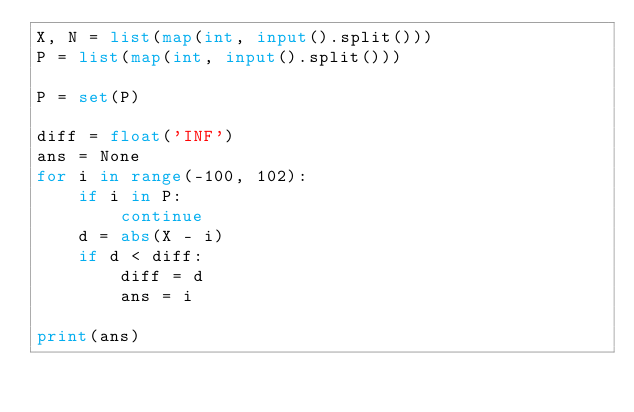<code> <loc_0><loc_0><loc_500><loc_500><_Python_>X, N = list(map(int, input().split()))
P = list(map(int, input().split()))

P = set(P)

diff = float('INF')
ans = None
for i in range(-100, 102):
    if i in P:
        continue
    d = abs(X - i)
    if d < diff:
        diff = d
        ans = i

print(ans)</code> 